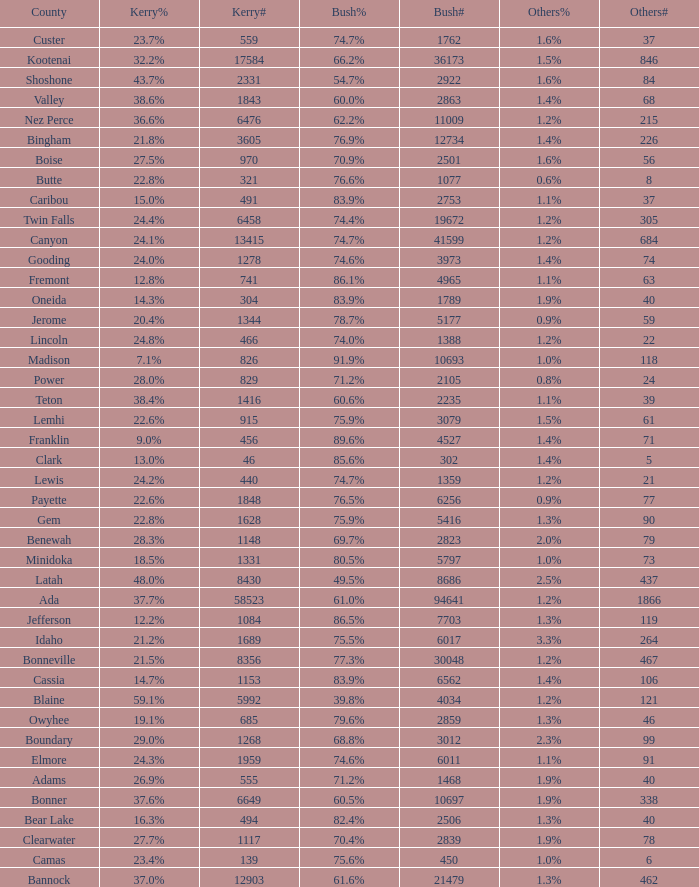How many different counts of the votes for Bush are there in the county where he got 69.7% of the votes? 1.0. 